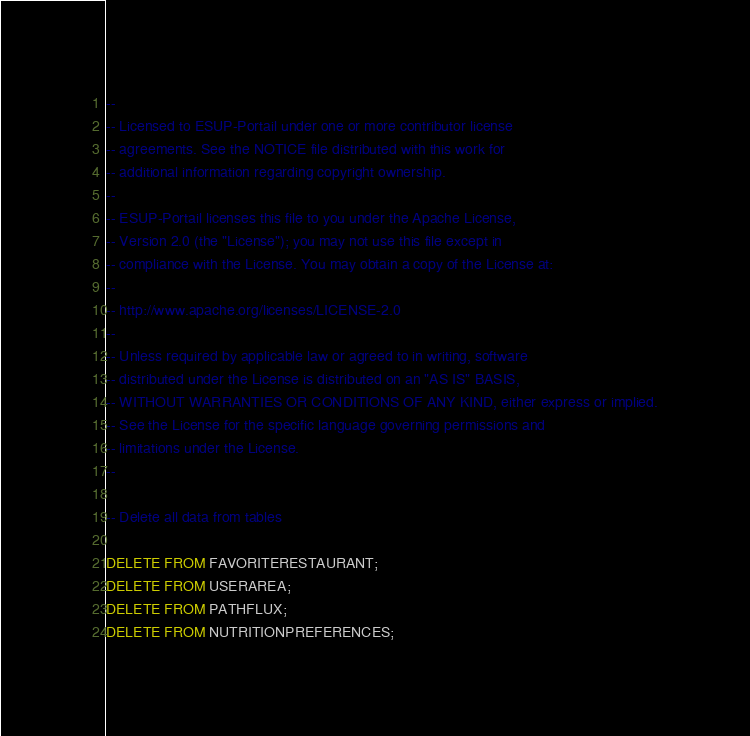<code> <loc_0><loc_0><loc_500><loc_500><_SQL_>--
-- Licensed to ESUP-Portail under one or more contributor license
-- agreements. See the NOTICE file distributed with this work for
-- additional information regarding copyright ownership.
--
-- ESUP-Portail licenses this file to you under the Apache License,
-- Version 2.0 (the "License"); you may not use this file except in
-- compliance with the License. You may obtain a copy of the License at:
--
-- http://www.apache.org/licenses/LICENSE-2.0
--
-- Unless required by applicable law or agreed to in writing, software
-- distributed under the License is distributed on an "AS IS" BASIS,
-- WITHOUT WARRANTIES OR CONDITIONS OF ANY KIND, either express or implied.
-- See the License for the specific language governing permissions and
-- limitations under the License.
--

-- Delete all data from tables

DELETE FROM FAVORITERESTAURANT;
DELETE FROM USERAREA;
DELETE FROM PATHFLUX;
DELETE FROM NUTRITIONPREFERENCES;</code> 